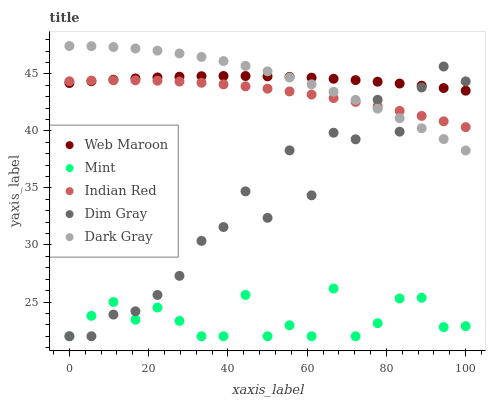Does Mint have the minimum area under the curve?
Answer yes or no. Yes. Does Web Maroon have the maximum area under the curve?
Answer yes or no. Yes. Does Dim Gray have the minimum area under the curve?
Answer yes or no. No. Does Dim Gray have the maximum area under the curve?
Answer yes or no. No. Is Web Maroon the smoothest?
Answer yes or no. Yes. Is Dim Gray the roughest?
Answer yes or no. Yes. Is Mint the smoothest?
Answer yes or no. No. Is Mint the roughest?
Answer yes or no. No. Does Mint have the lowest value?
Answer yes or no. Yes. Does Web Maroon have the lowest value?
Answer yes or no. No. Does Dark Gray have the highest value?
Answer yes or no. Yes. Does Dim Gray have the highest value?
Answer yes or no. No. Is Mint less than Web Maroon?
Answer yes or no. Yes. Is Indian Red greater than Mint?
Answer yes or no. Yes. Does Web Maroon intersect Dim Gray?
Answer yes or no. Yes. Is Web Maroon less than Dim Gray?
Answer yes or no. No. Is Web Maroon greater than Dim Gray?
Answer yes or no. No. Does Mint intersect Web Maroon?
Answer yes or no. No. 